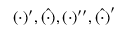<formula> <loc_0><loc_0><loc_500><loc_500>( \cdot ) ^ { \prime } , \hat { ( \cdot ) } , ( \cdot ) ^ { \prime \prime } , \hat { ( \cdot ) } ^ { \prime }</formula> 